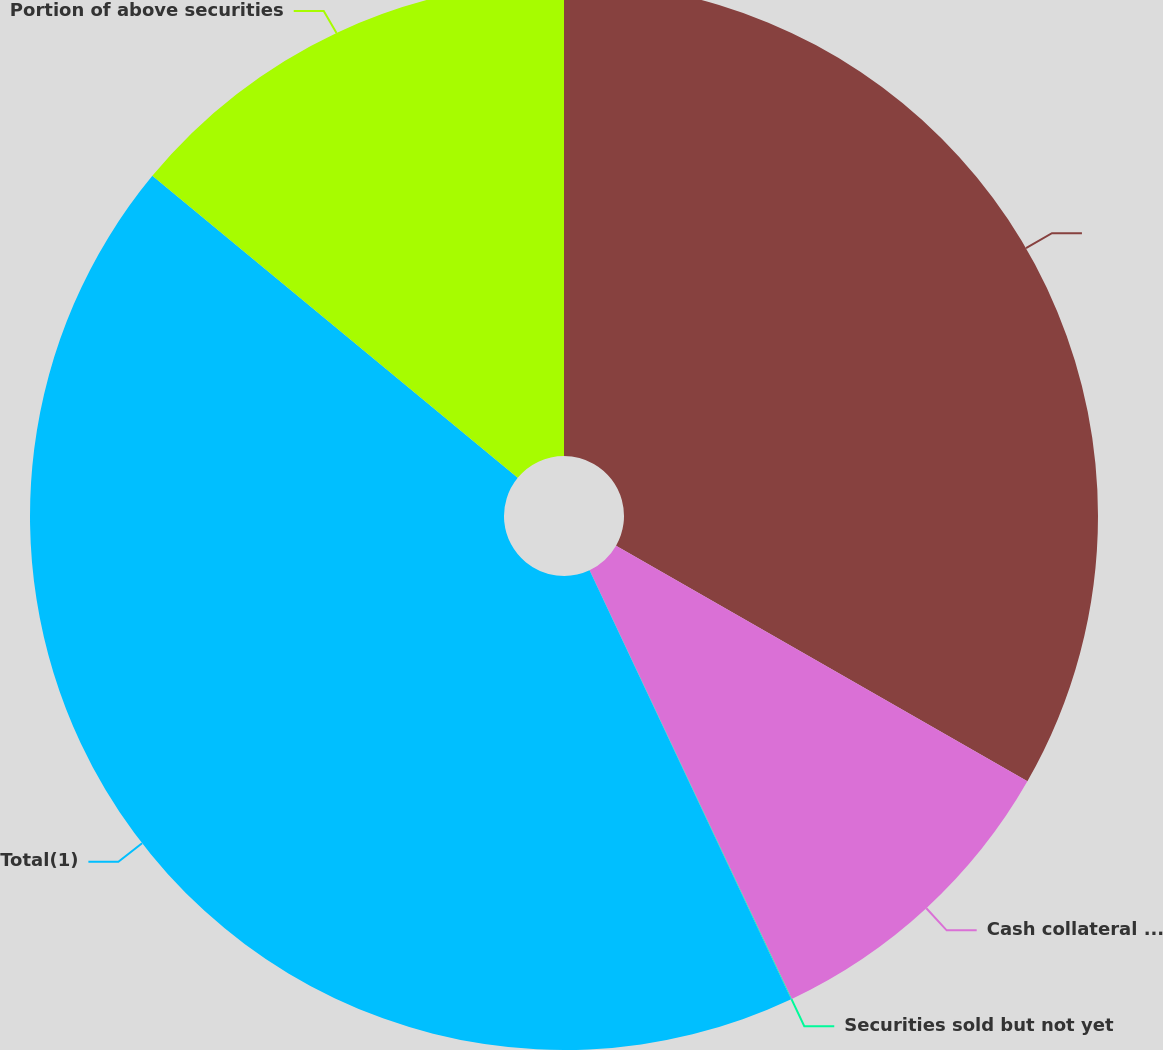Convert chart. <chart><loc_0><loc_0><loc_500><loc_500><pie_chart><ecel><fcel>Cash collateral for loaned<fcel>Securities sold but not yet<fcel>Total(1)<fcel>Portion of above securities<nl><fcel>33.28%<fcel>9.71%<fcel>0.02%<fcel>42.99%<fcel>14.01%<nl></chart> 